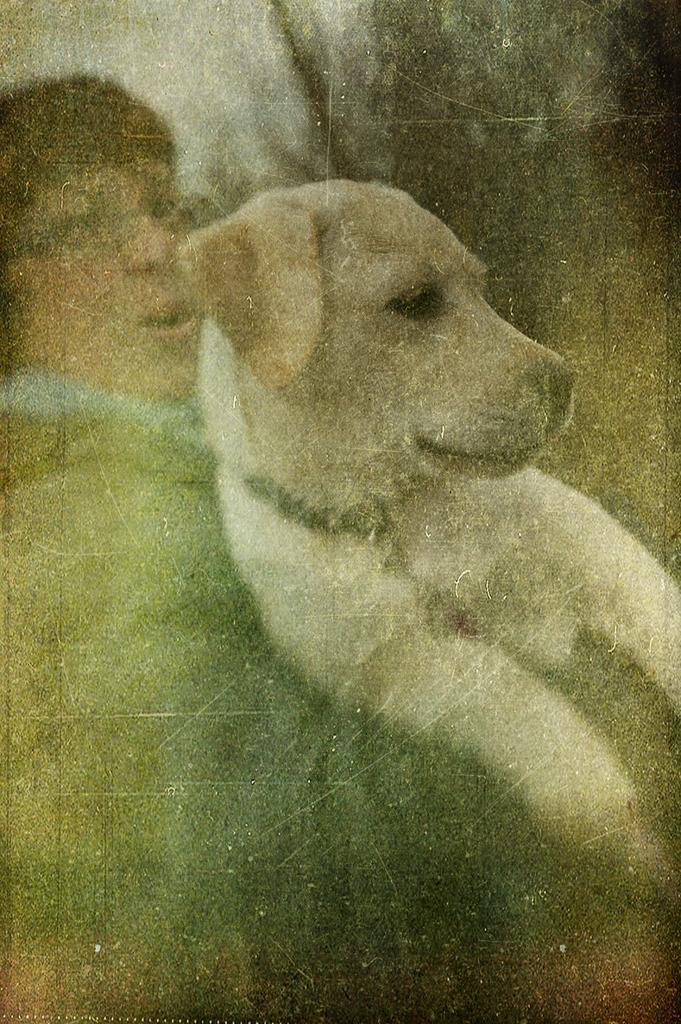What is the main subject of the image? There is a human in the image. What is the human doing in the image? The human is holding a dog. Can you describe the background of the image? The background of the image is blurry. How many passengers are visible in the image? There is no reference to passengers in the image, as it features a human holding a dog. What type of knot is being tied by the human in the image? There is no knot-tying activity depicted in the image; the human is holding a dog. 